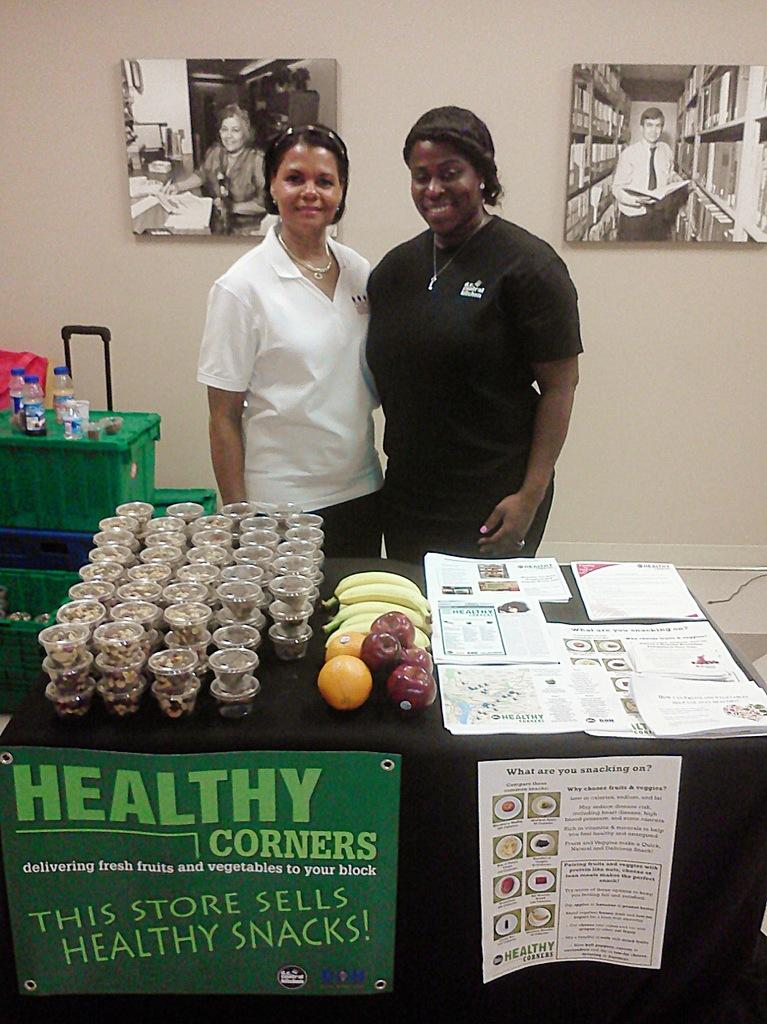What type of furniture is present in the image? There are tables in the image. What items can be seen on the tables? Cups and bottles are visible on the tables in the image. What type of food items are present in the image? Fruits are present in the image. What other objects can be seen in the image? Papers are present in the image. How many people are visible in the image? There are two people standing in the image. What is the background of the image? There is a wall in the image. Are there any decorations on the wall? Yes, there are two photos on the wall. What type of holiday is being celebrated in the image? There is no indication of a holiday being celebrated in the image. What type of loaf is being served on the table? There is no loaf present in the image. How many beads are visible on the wall? There are no beads visible on the wall in the image. 